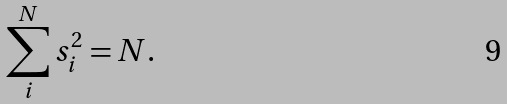<formula> <loc_0><loc_0><loc_500><loc_500>\sum _ { i } ^ { N } s _ { i } ^ { 2 } = N .</formula> 